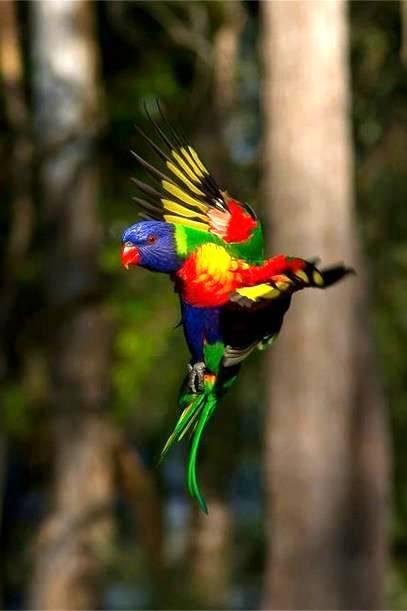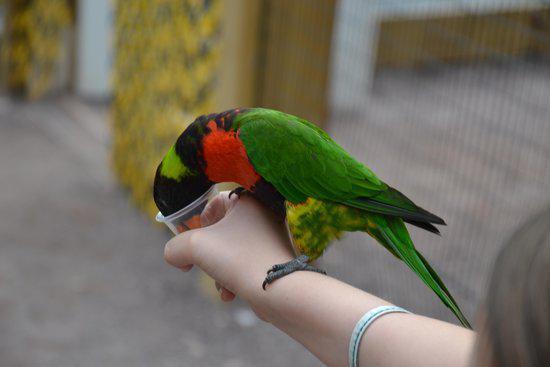The first image is the image on the left, the second image is the image on the right. Given the left and right images, does the statement "There are exactly two birds in the image on the right." hold true? Answer yes or no. No. 